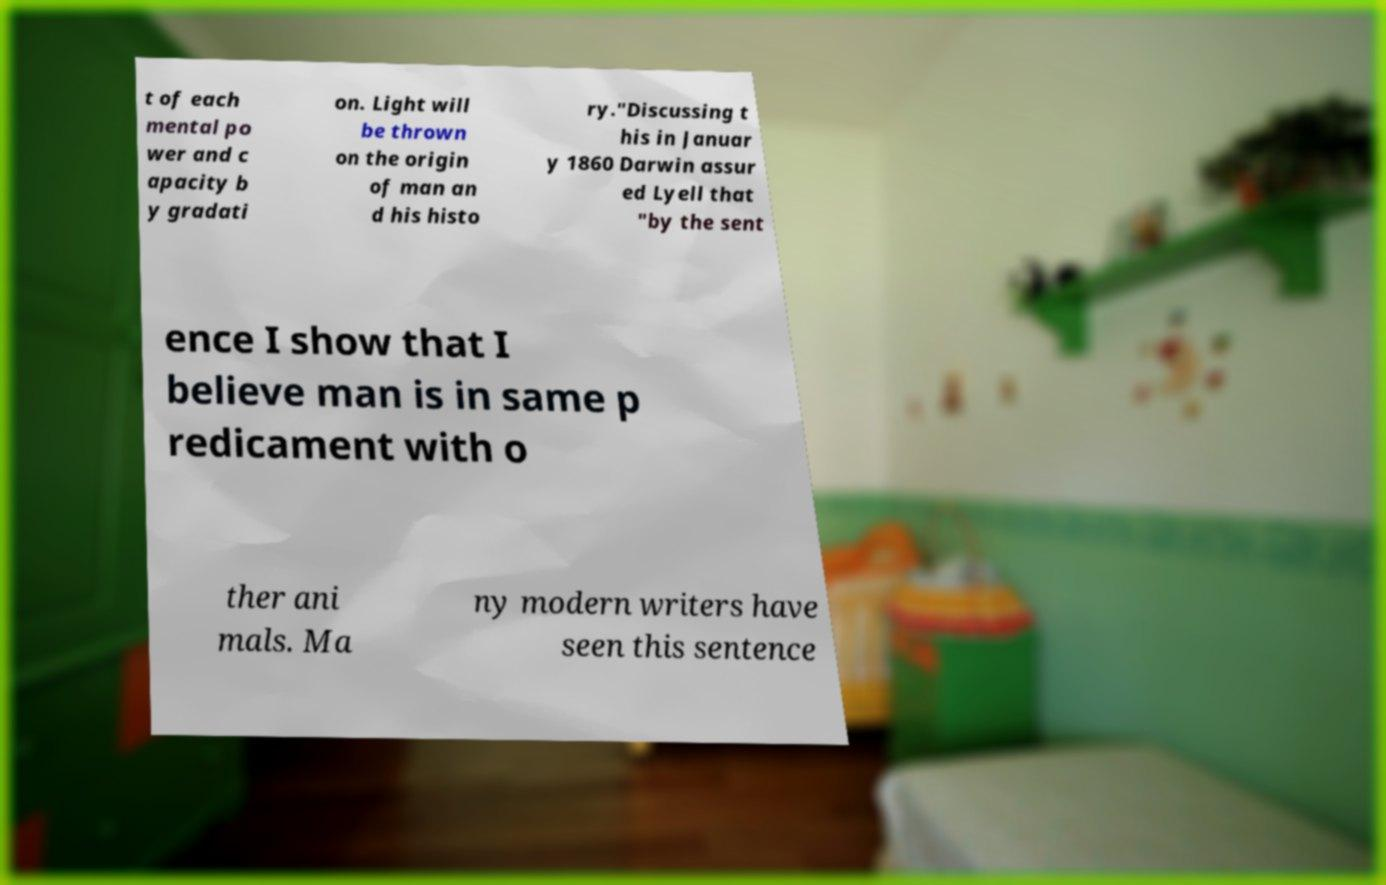I need the written content from this picture converted into text. Can you do that? t of each mental po wer and c apacity b y gradati on. Light will be thrown on the origin of man an d his histo ry."Discussing t his in Januar y 1860 Darwin assur ed Lyell that "by the sent ence I show that I believe man is in same p redicament with o ther ani mals. Ma ny modern writers have seen this sentence 